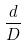<formula> <loc_0><loc_0><loc_500><loc_500>\frac { d } { D }</formula> 